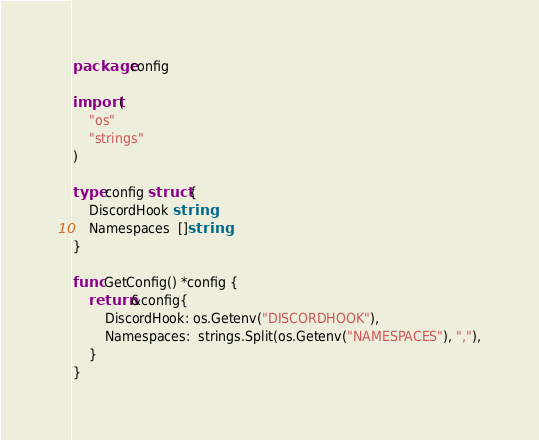Convert code to text. <code><loc_0><loc_0><loc_500><loc_500><_Go_>package config

import (
	"os"
	"strings"
)

type config struct {
	DiscordHook string
	Namespaces  []string
}

func GetConfig() *config {
	return &config{
		DiscordHook: os.Getenv("DISCORDHOOK"),
		Namespaces:  strings.Split(os.Getenv("NAMESPACES"), ","),
	}
}
</code> 